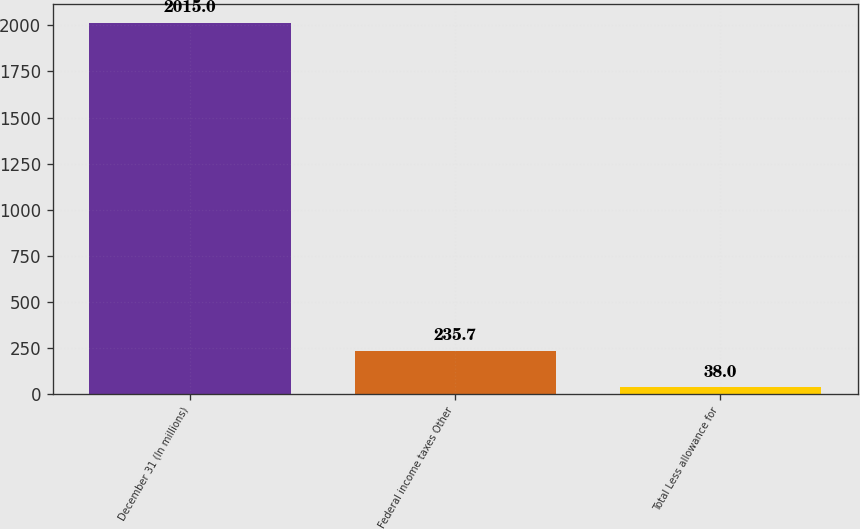Convert chart. <chart><loc_0><loc_0><loc_500><loc_500><bar_chart><fcel>December 31 (In millions)<fcel>Federal income taxes Other<fcel>Total Less allowance for<nl><fcel>2015<fcel>235.7<fcel>38<nl></chart> 